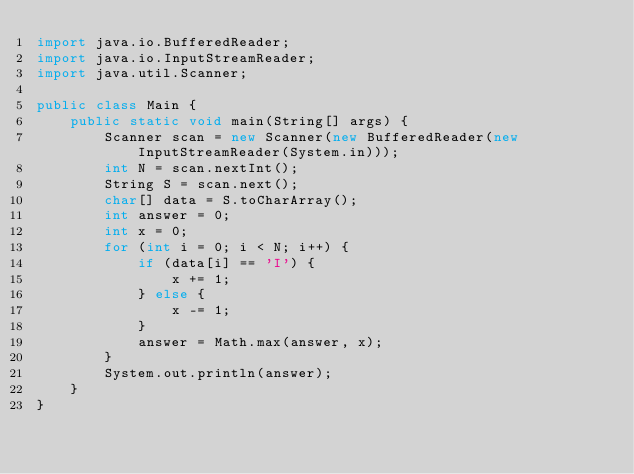<code> <loc_0><loc_0><loc_500><loc_500><_Java_>import java.io.BufferedReader;
import java.io.InputStreamReader;
import java.util.Scanner;

public class Main {
    public static void main(String[] args) {
        Scanner scan = new Scanner(new BufferedReader(new InputStreamReader(System.in)));
        int N = scan.nextInt();
        String S = scan.next();
        char[] data = S.toCharArray();
        int answer = 0;
        int x = 0;
        for (int i = 0; i < N; i++) {
            if (data[i] == 'I') {
                x += 1;
            } else {
                x -= 1;
            }
            answer = Math.max(answer, x);
        }
        System.out.println(answer);
    }
}
</code> 